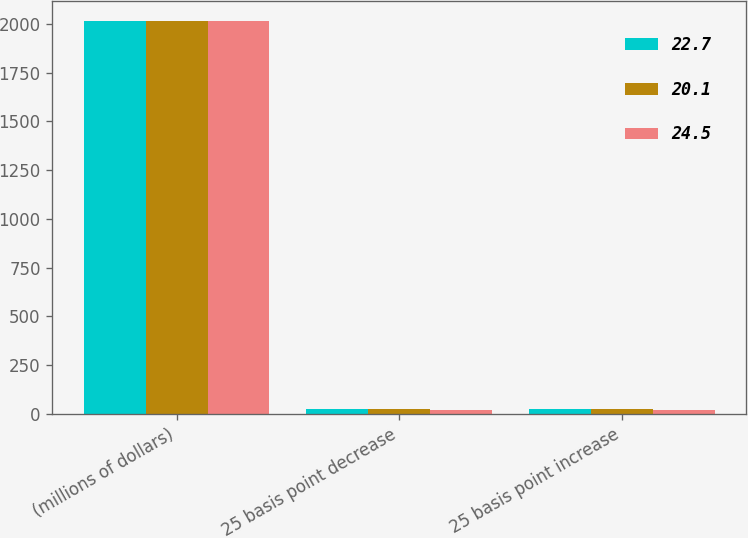Convert chart to OTSL. <chart><loc_0><loc_0><loc_500><loc_500><stacked_bar_chart><ecel><fcel>(millions of dollars)<fcel>25 basis point decrease<fcel>25 basis point increase<nl><fcel>22.7<fcel>2017<fcel>24.5<fcel>24.5<nl><fcel>20.1<fcel>2016<fcel>22.7<fcel>22.7<nl><fcel>24.5<fcel>2015<fcel>20.1<fcel>20.1<nl></chart> 